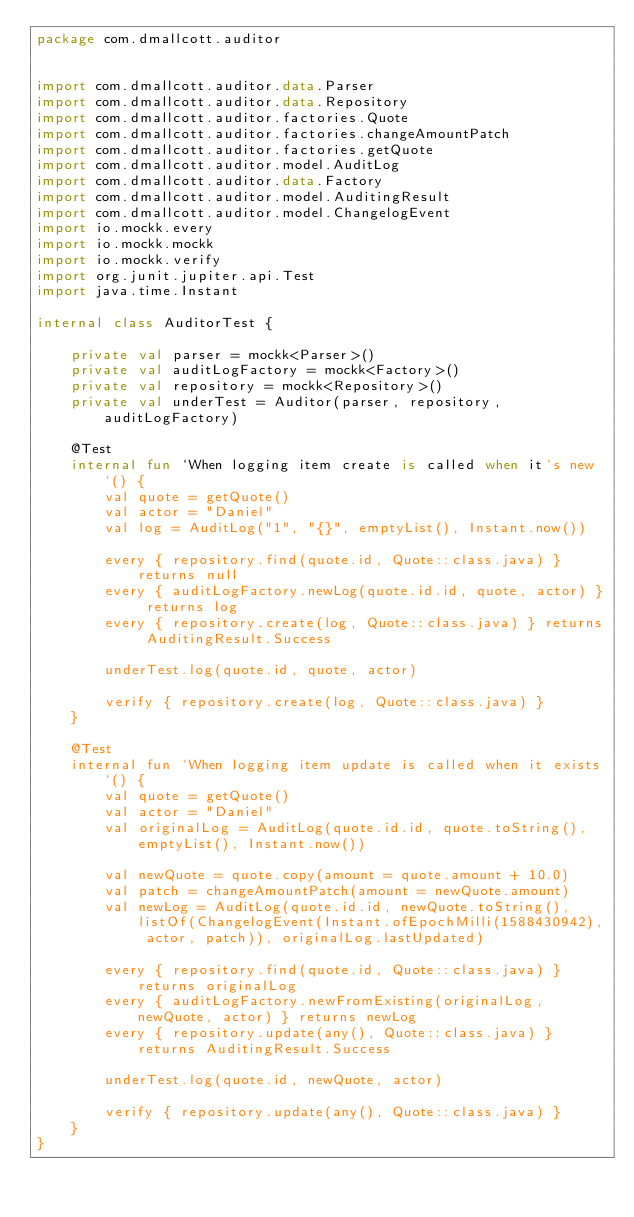<code> <loc_0><loc_0><loc_500><loc_500><_Kotlin_>package com.dmallcott.auditor


import com.dmallcott.auditor.data.Parser
import com.dmallcott.auditor.data.Repository
import com.dmallcott.auditor.factories.Quote
import com.dmallcott.auditor.factories.changeAmountPatch
import com.dmallcott.auditor.factories.getQuote
import com.dmallcott.auditor.model.AuditLog
import com.dmallcott.auditor.data.Factory
import com.dmallcott.auditor.model.AuditingResult
import com.dmallcott.auditor.model.ChangelogEvent
import io.mockk.every
import io.mockk.mockk
import io.mockk.verify
import org.junit.jupiter.api.Test
import java.time.Instant

internal class AuditorTest {

    private val parser = mockk<Parser>()
    private val auditLogFactory = mockk<Factory>()
    private val repository = mockk<Repository>()
    private val underTest = Auditor(parser, repository, auditLogFactory)

    @Test
    internal fun `When logging item create is called when it's new`() {
        val quote = getQuote()
        val actor = "Daniel"
        val log = AuditLog("1", "{}", emptyList(), Instant.now())

        every { repository.find(quote.id, Quote::class.java) } returns null
        every { auditLogFactory.newLog(quote.id.id, quote, actor) } returns log
        every { repository.create(log, Quote::class.java) } returns AuditingResult.Success

        underTest.log(quote.id, quote, actor)

        verify { repository.create(log, Quote::class.java) }
    }

    @Test
    internal fun `When logging item update is called when it exists`() {
        val quote = getQuote()
        val actor = "Daniel"
        val originalLog = AuditLog(quote.id.id, quote.toString(), emptyList(), Instant.now())

        val newQuote = quote.copy(amount = quote.amount + 10.0)
        val patch = changeAmountPatch(amount = newQuote.amount)
        val newLog = AuditLog(quote.id.id, newQuote.toString(), listOf(ChangelogEvent(Instant.ofEpochMilli(1588430942), actor, patch)), originalLog.lastUpdated)

        every { repository.find(quote.id, Quote::class.java) } returns originalLog
        every { auditLogFactory.newFromExisting(originalLog, newQuote, actor) } returns newLog
        every { repository.update(any(), Quote::class.java) } returns AuditingResult.Success

        underTest.log(quote.id, newQuote, actor)

        verify { repository.update(any(), Quote::class.java) }
    }
}</code> 